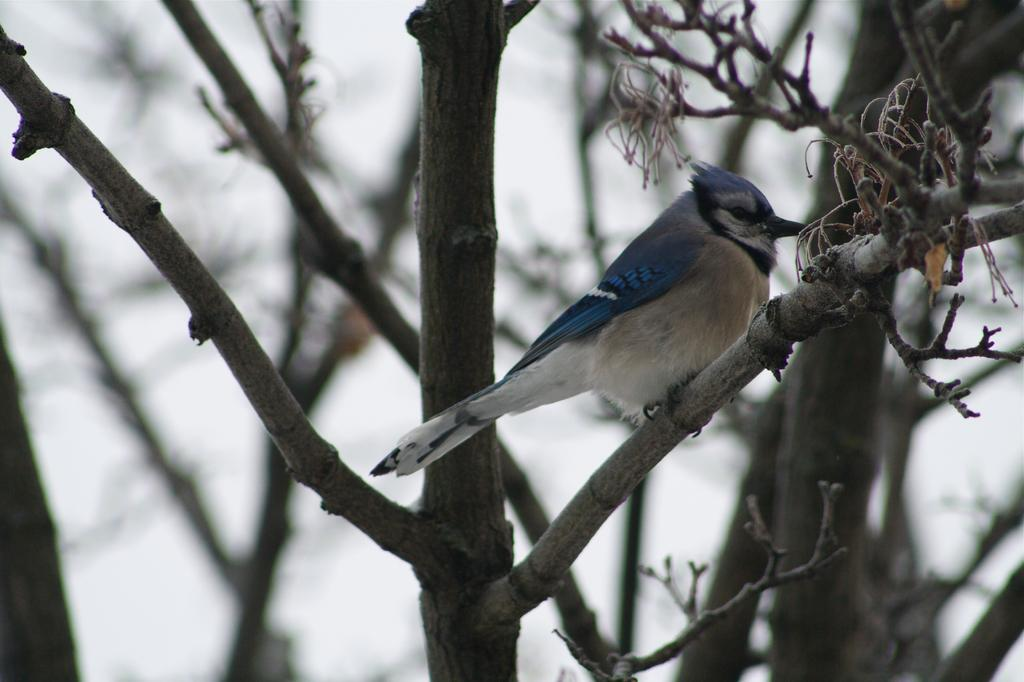What type of animal can be seen in the image? There is a bird in the image. What is the bird perched on in the image? There is a tree in the image. What type of shock can be seen affecting the bird in the image? There is no shock present in the image; it simply features a bird perched on a tree. How does the bird use its hand to interact with the tree in the image? Birds do not have hands, so this question is not applicable to the image. 